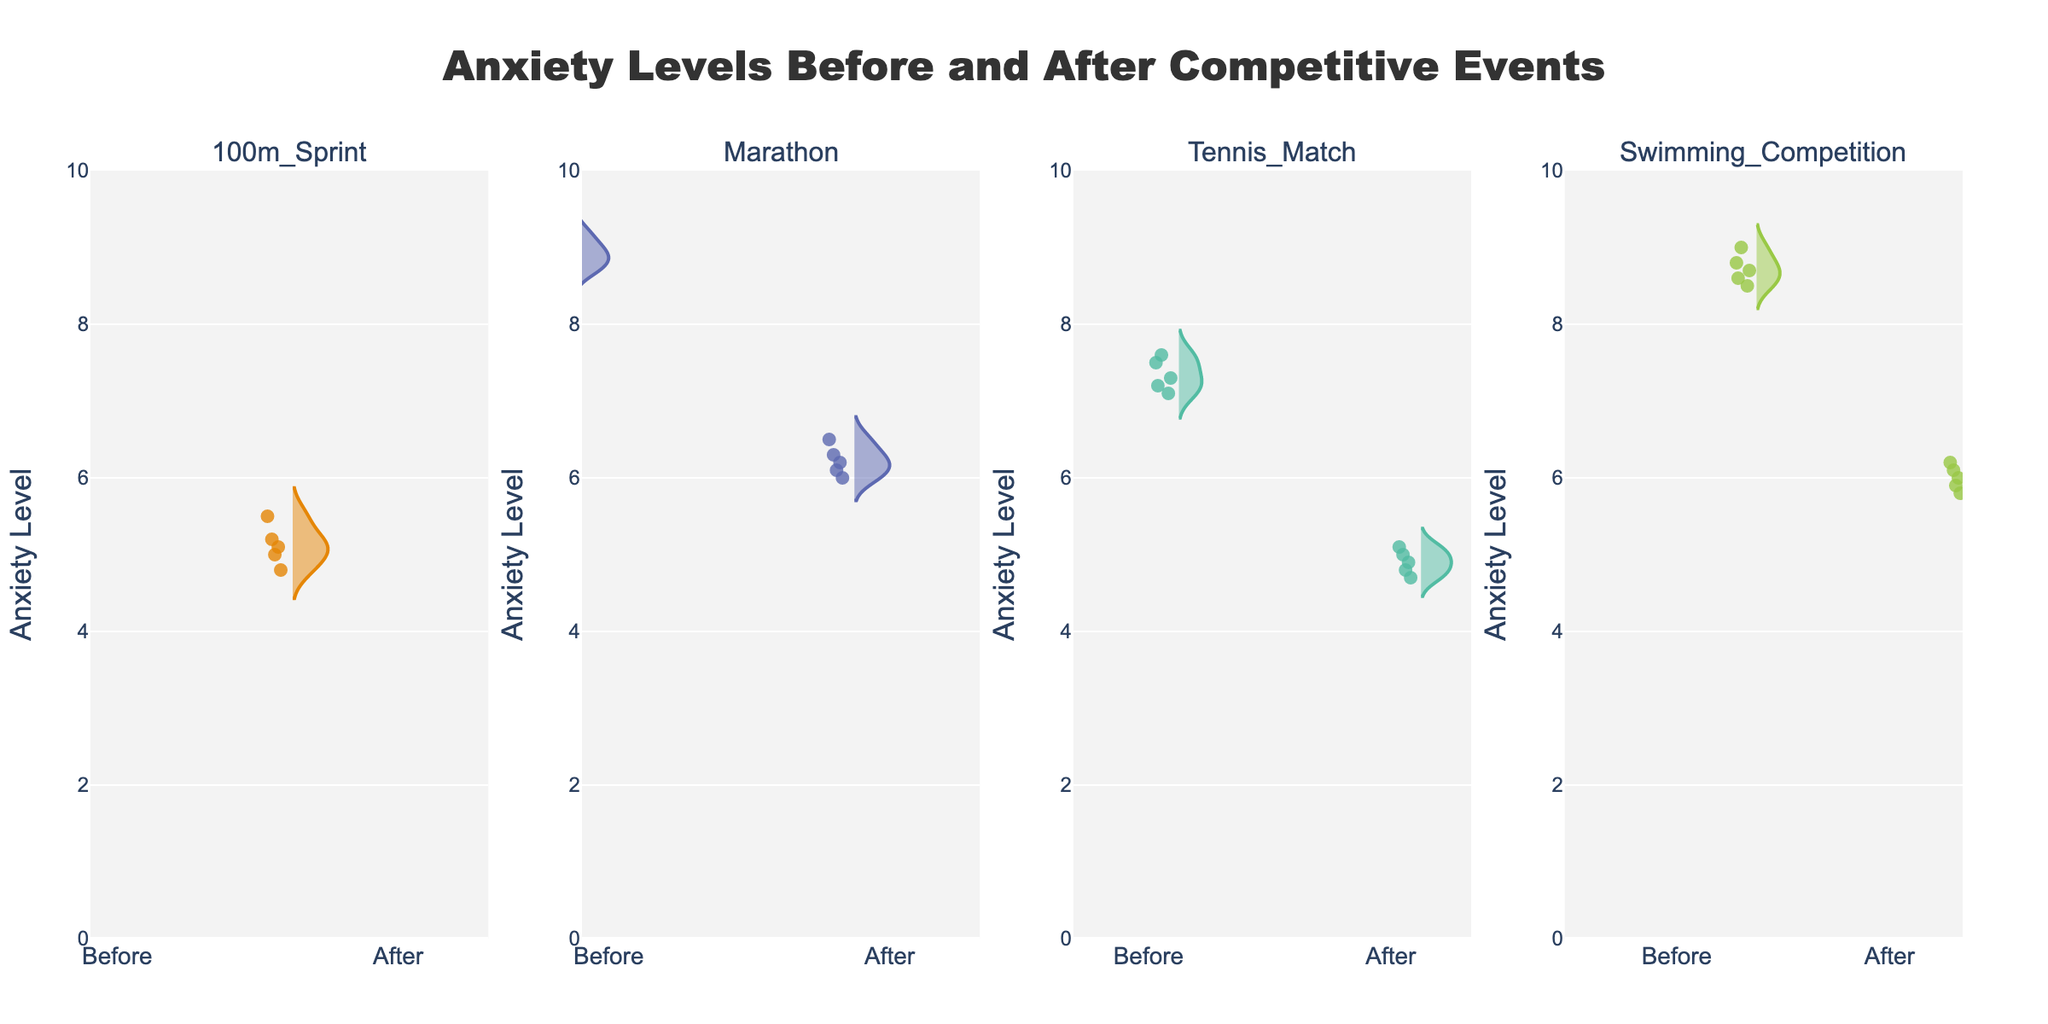What is the title of the violin chart? The title is usually found at the top of the figure and summarizes the main content. In this case, it says "Anxiety Levels Before and After Competitive Events."
Answer: Anxiety Levels Before and After Competitive Events How many competitive events are compared in the figure? By counting the number of subplot titles, you can see that there are four events: 100m Sprint, Marathon, Tennis Match, and Swimming Competition.
Answer: Four Which event shows the highest average anxiety level before the event? By looking at the densities and general position of the violin plots for 'Before' across all events, the highest average appears to be for the Marathon.
Answer: Marathon What is the anxiety level range for 'After' the Swimming Competition? The range of a distribution is found from the minimum to the maximum values. For 'After' the Swimming Competition, it ranges from 5.8 to 6.2.
Answer: 5.8 to 6.2 Is there any event where the anxiety levels are lower after the event compared to before? By comparing the 'Before' and 'After' sections of each event's violin plot, it's clear that all events show lower anxiety levels after the event.
Answer: Yes, all events Which event has the least decrease in anxiety levels from 'Before' to 'After'? To find this, look at the difference in the median points of the 'Before' and 'After' plots for each event. The Marathon shows the smallest decrease.
Answer: Marathon What is the general shape of the anxiety level distribution for the 100m Sprint before the event? The shape is shown by the violin plot density. For the 100m Sprint 'Before,' it's relatively narrow and centered around 8.0-8.5.
Answer: Narrow around 8.0-8.5 How does the variability of anxiety levels before the Tennis Match compare to after? The 'Before' plot for Tennis Match shows more spread-out points and a wider density, whereas the 'After' plot is more compact. This means higher variability 'Before' and lower 'After.'
Answer: Higher before Which event has the highest median anxiety level after the event? The median can usually be estimated by the highest density point in the violin plot. For 'After' values, the Marathon appears to have the highest median.
Answer: Marathon 